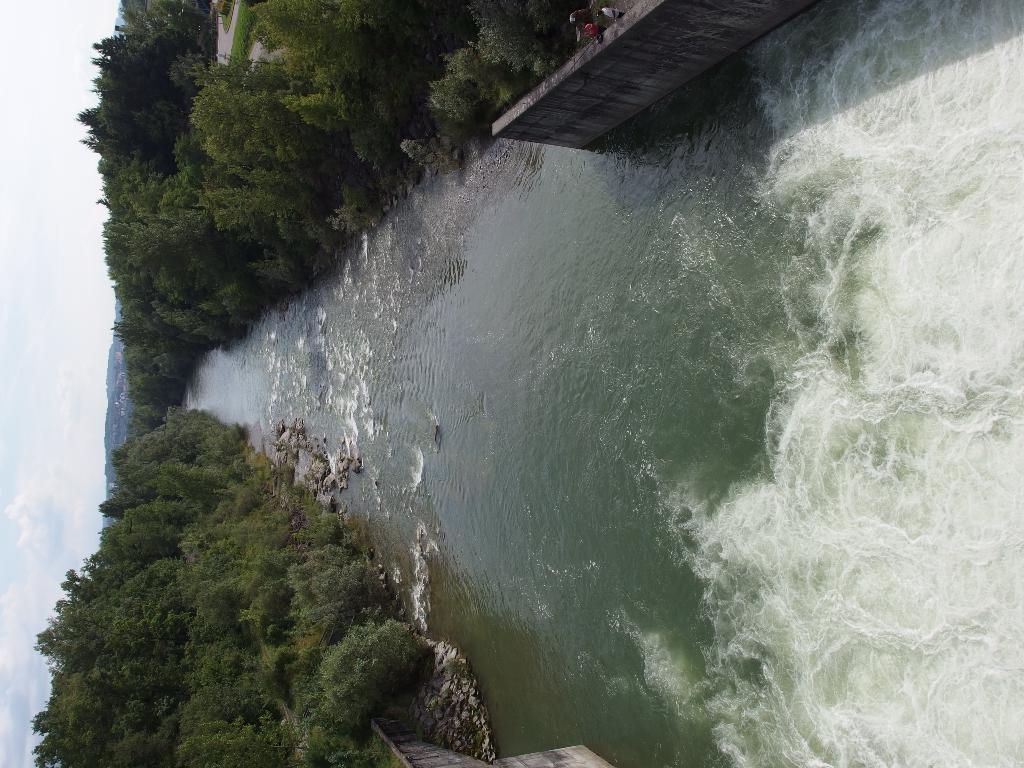How would you summarize this image in a sentence or two? There is a river. On the sides of the river there are trees, rocks and a wall. On the left side there is sky. 